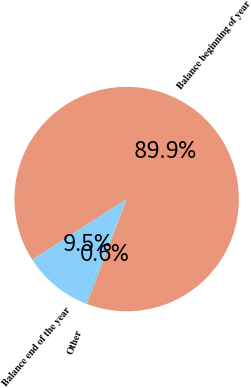<chart> <loc_0><loc_0><loc_500><loc_500><pie_chart><fcel>Balance beginning of year<fcel>Other<fcel>Balance end of the year<nl><fcel>89.87%<fcel>0.6%<fcel>9.53%<nl></chart> 